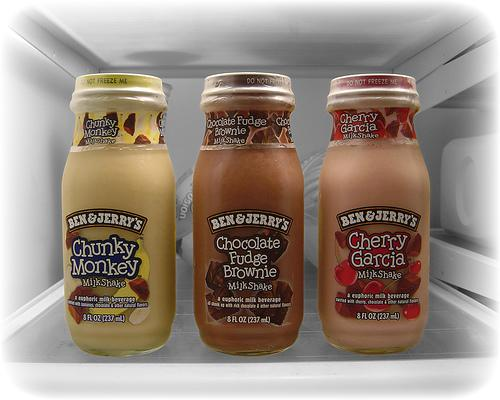Question: what milkshake has cherries?
Choices:
A. Vamilla.
B. Chocolate.
C. Banana.
D. Cherry garcia.
Answer with the letter. Answer: D Question: how many ounces?
Choices:
A. 8.
B. 16.
C. 24.
D. 32.
Answer with the letter. Answer: A Question: how many milkshakes?
Choices:
A. 3.
B. 1.
C. 2.
D. 4.
Answer with the letter. Answer: A Question: what are the bottles in?
Choices:
A. Refrigerator.
B. Cupboard.
C. Soda machine.
D. Milk crate.
Answer with the letter. Answer: A 